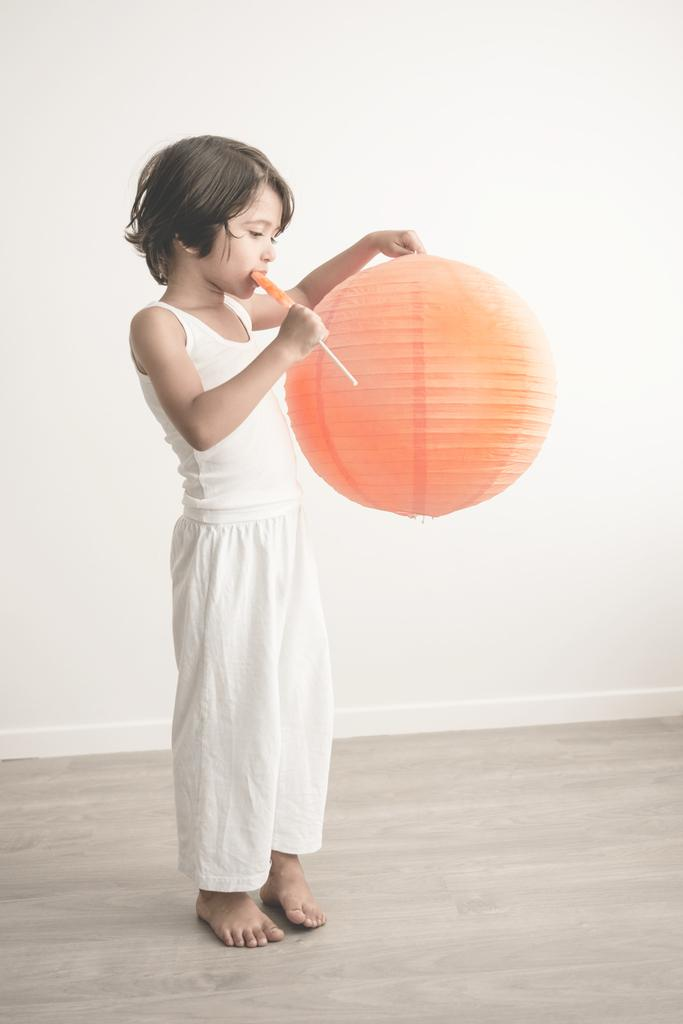Who is the main subject in the image? There is a girl in the image. What is the girl doing in the image? The girl is standing in the image. What is the girl holding in the image? The girl is holding an ice-cream and a paper ball in the image. What can be seen in the background of the image? There is a wall in the image, and it is white in color. What type of necklace is the girl wearing in the image? There is no mention of a necklace in the provided facts, so we cannot determine if the girl is wearing one in the image. 